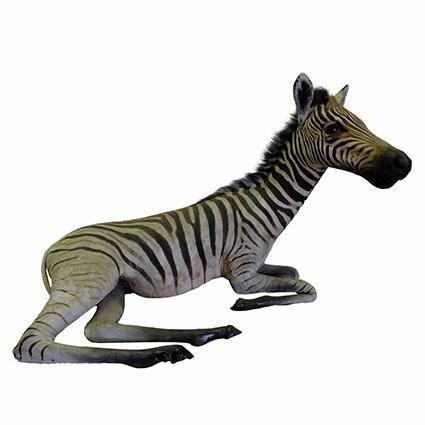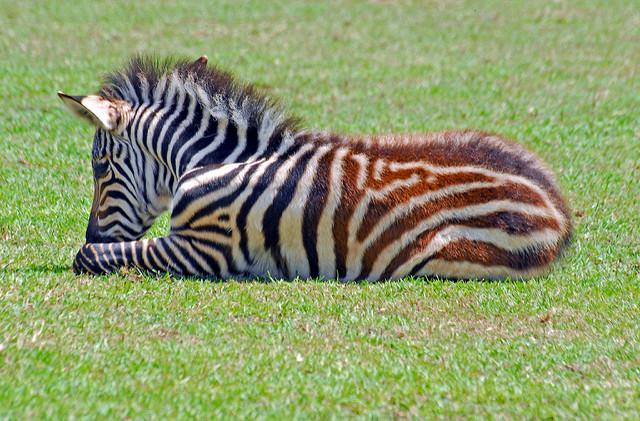The first image is the image on the left, the second image is the image on the right. Given the left and right images, does the statement "The zebra in the image on the left is standing in a field." hold true? Answer yes or no. No. 